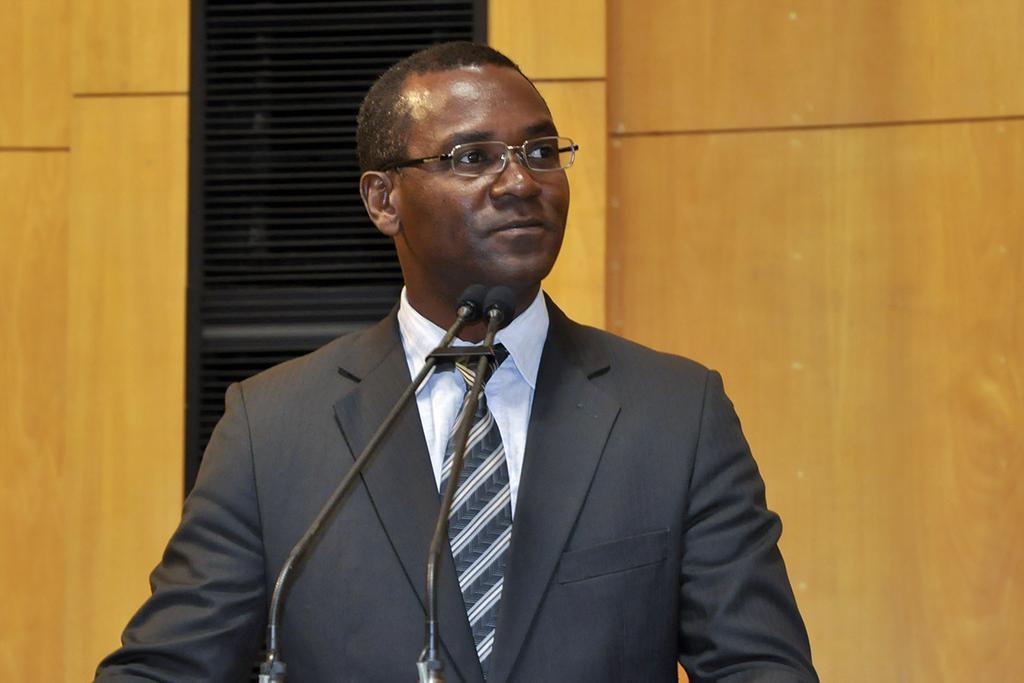Could you give a brief overview of what you see in this image? This image consists of a man wearing a black suit along with a tie. In front of him, we can see two mics. In the background, there is a wall. It looks like it is made up of wood. 